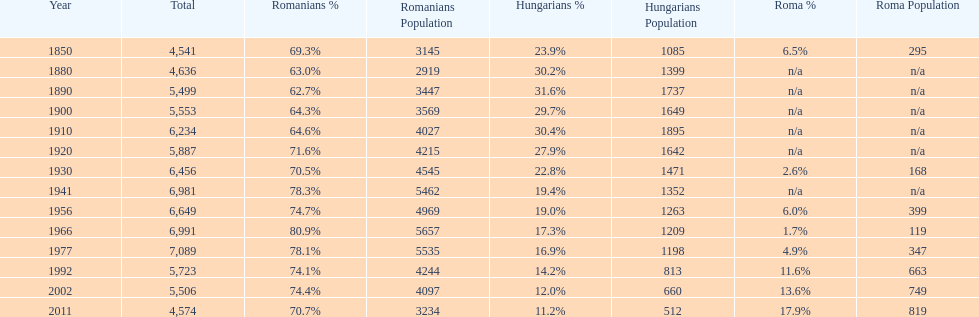Which year had a total of 6,981 and 19.4% hungarians? 1941. 